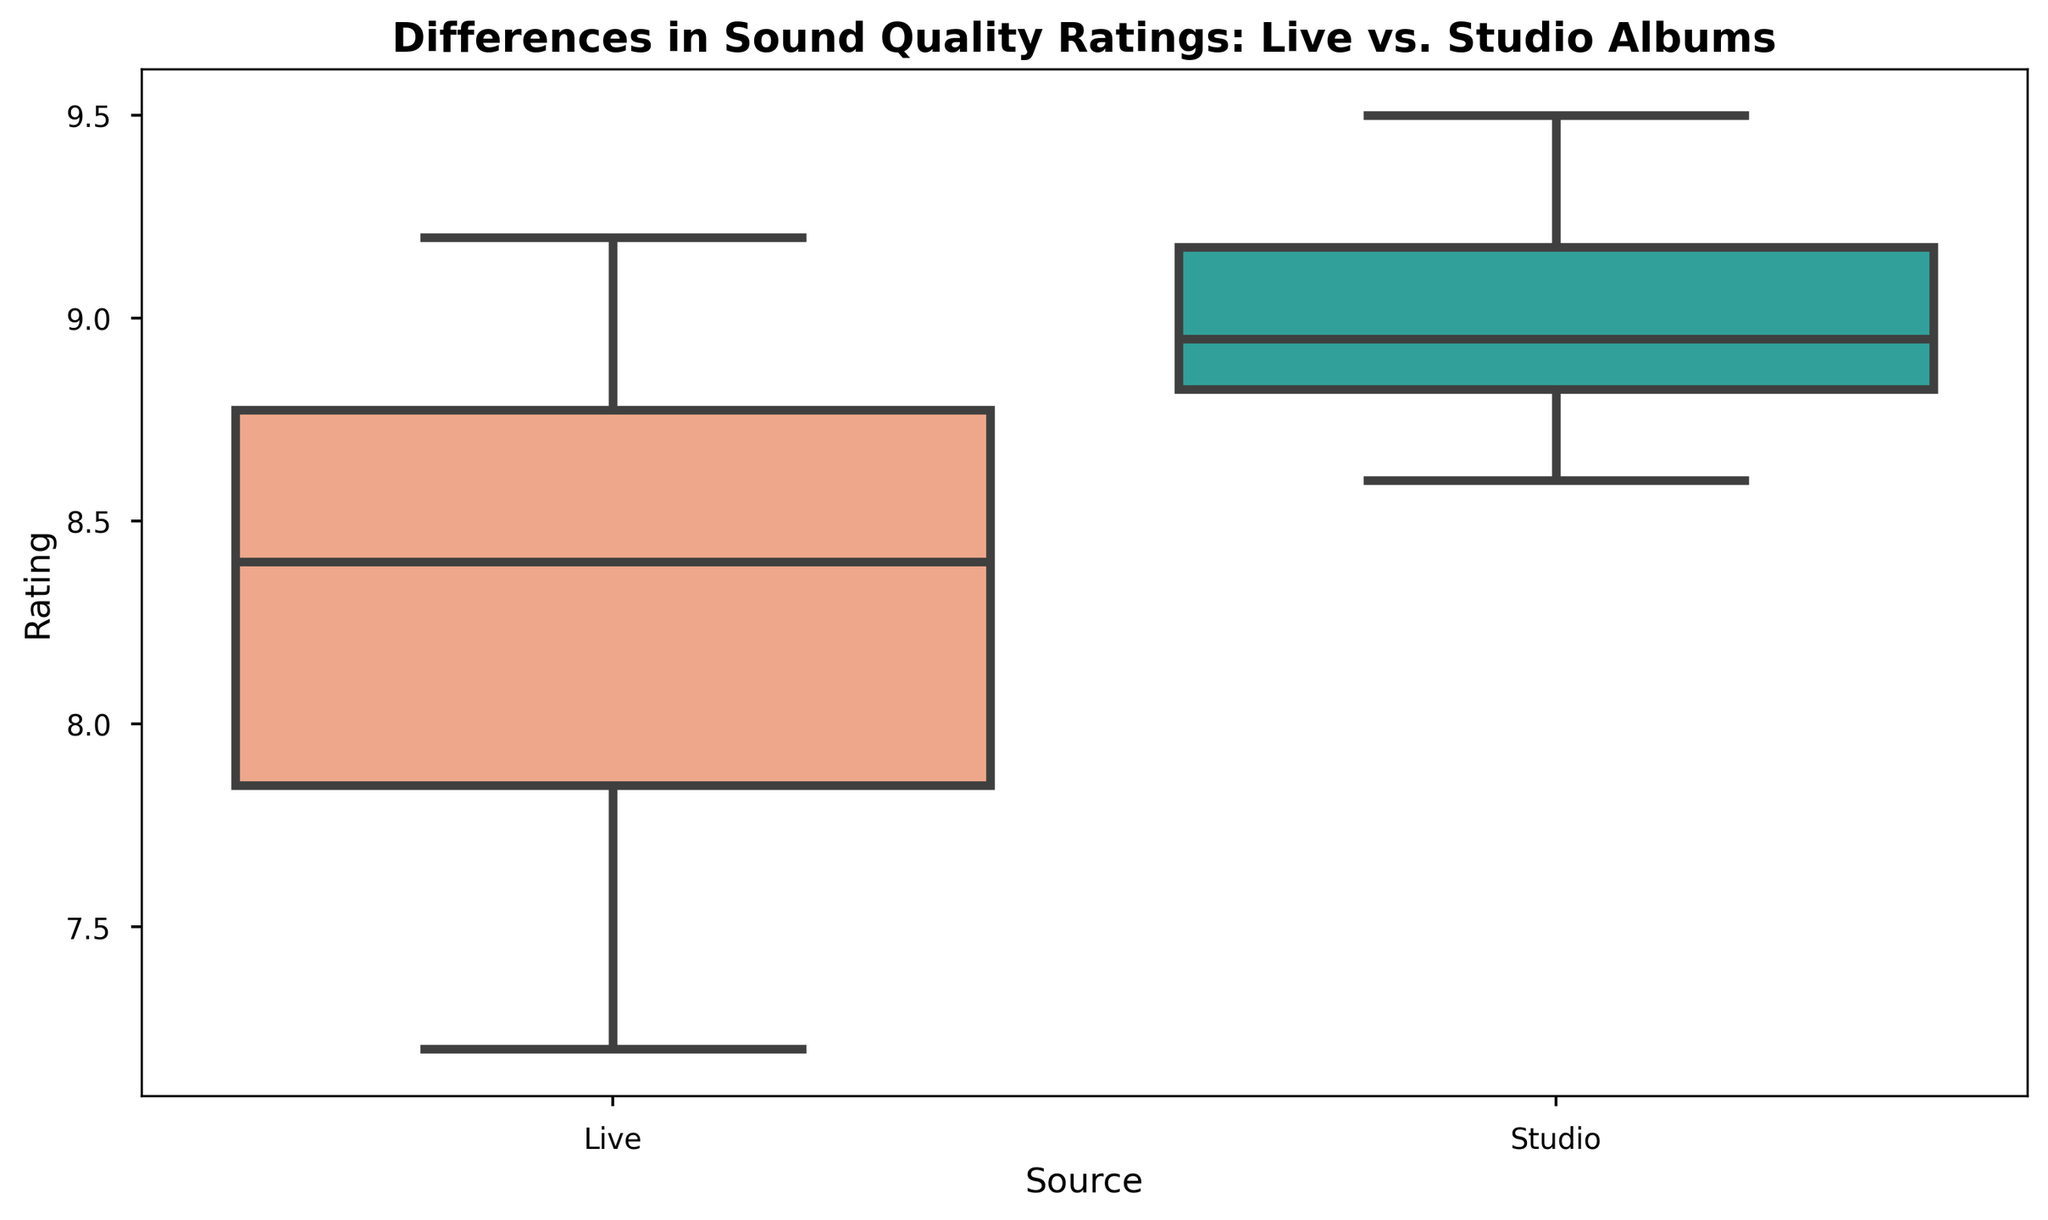Which type of album has a higher median rating? The median of the box plot indicates the middle value of the data when it is ordered. By comparing the center lines of the two boxes, we see that the median line for Studio albums is higher than that for Live albums.
Answer: Studio What is the interquartile range (IQR) for Live albums? The IQR is calculated as the difference between the upper quartile (Q3) and the lower quartile (Q1). The upper quartile for Live albums appears around 8.7 and the lower quartile around 7.8, making the IQR 8.7 - 7.8.
Answer: 0.9 Which type of album has more variability in ratings? The variability can be observed by looking at the span of the boxes and whiskers. The box and whiskers span wider for Live albums compared to Studio albums, indicating greater variability.
Answer: Live Are there any outliers in the box plot? Outliers usually appear as individual points outside the whiskers. By looking at the plot, there are no points that lie outside the whiskers for either Live or Studio albums.
Answer: No What’s the difference between the upper quartile of Studio albums and the median of Live albums? The upper quartile (Q3) of Studio albums is around 9.2 and the median of Live albums is around 8.3. Subtracting 8.3 from 9.2 gives us 0.9.
Answer: 0.9 Which group has a narrower range between the upper and lower whiskers? The range of the whiskers represents the spread of the entire dataset. The whiskers for Studio albums are shorter compared to Live albums, indicating a narrower range.
Answer: Studio What rating defines the lower quartile for Studio albums? The lower quartile (Q1) is the left edge of the box. For Studio albums, this value is approximately 8.7.
Answer: 8.7 What is the median value of Live albums? The median value is the line inside the box. For Live albums, this value is around 8.3.
Answer: 8.3 